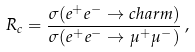Convert formula to latex. <formula><loc_0><loc_0><loc_500><loc_500>R _ { c } = \frac { \sigma ( e ^ { + } e ^ { - } \to c h a r m ) } { \sigma ( e ^ { + } e ^ { - } \to \mu ^ { + } \mu ^ { - } ) } \, ,</formula> 